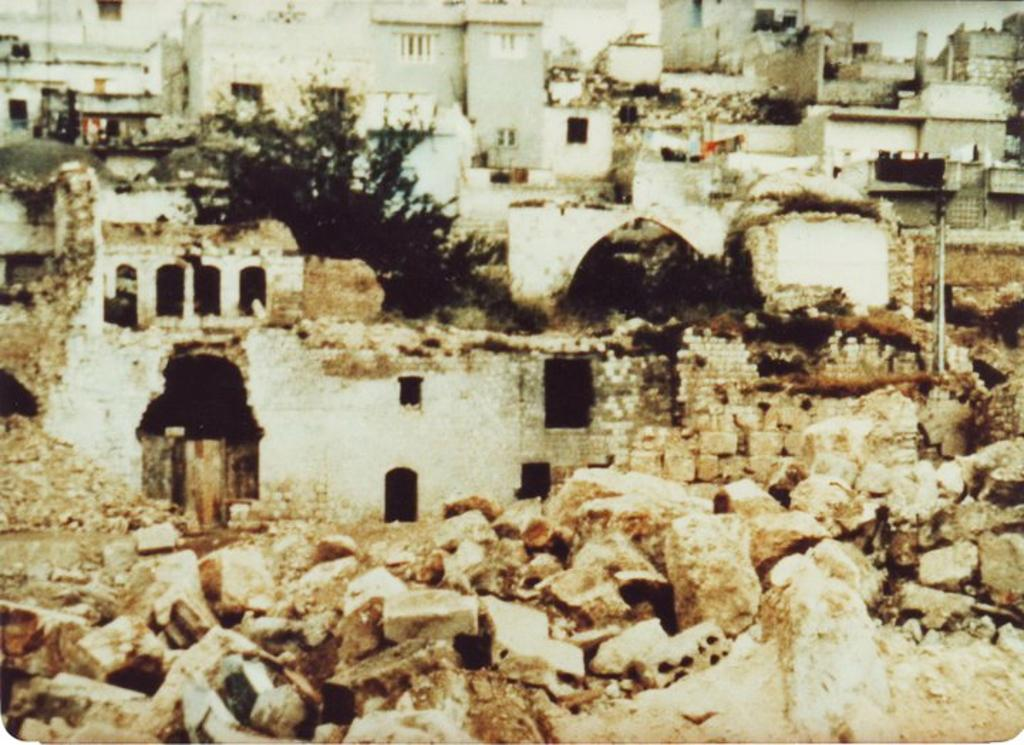What type of natural elements can be seen in the image? There are rocks in the image. What type of man-made structures are present in the image? There are houses in the image. What type of vegetation is visible in the image? There are trees in the image. How many dogs can be seen jumping over the rocks in the image? There are no dogs or jumping activities present in the image. What type of liquid can be seen dropping from the trees in the image? There is no liquid dropping from the trees in the image; only rocks, houses, and trees are present. 